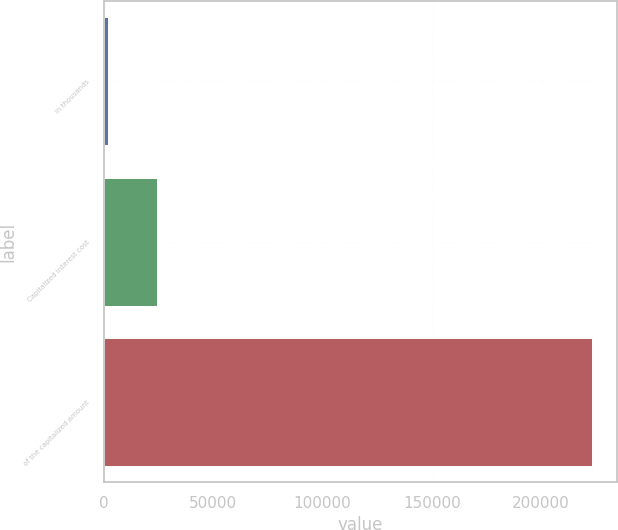Convert chart to OTSL. <chart><loc_0><loc_0><loc_500><loc_500><bar_chart><fcel>in thousands<fcel>Capitalized interest cost<fcel>of the capitalized amount<nl><fcel>2015<fcel>24165.3<fcel>223518<nl></chart> 